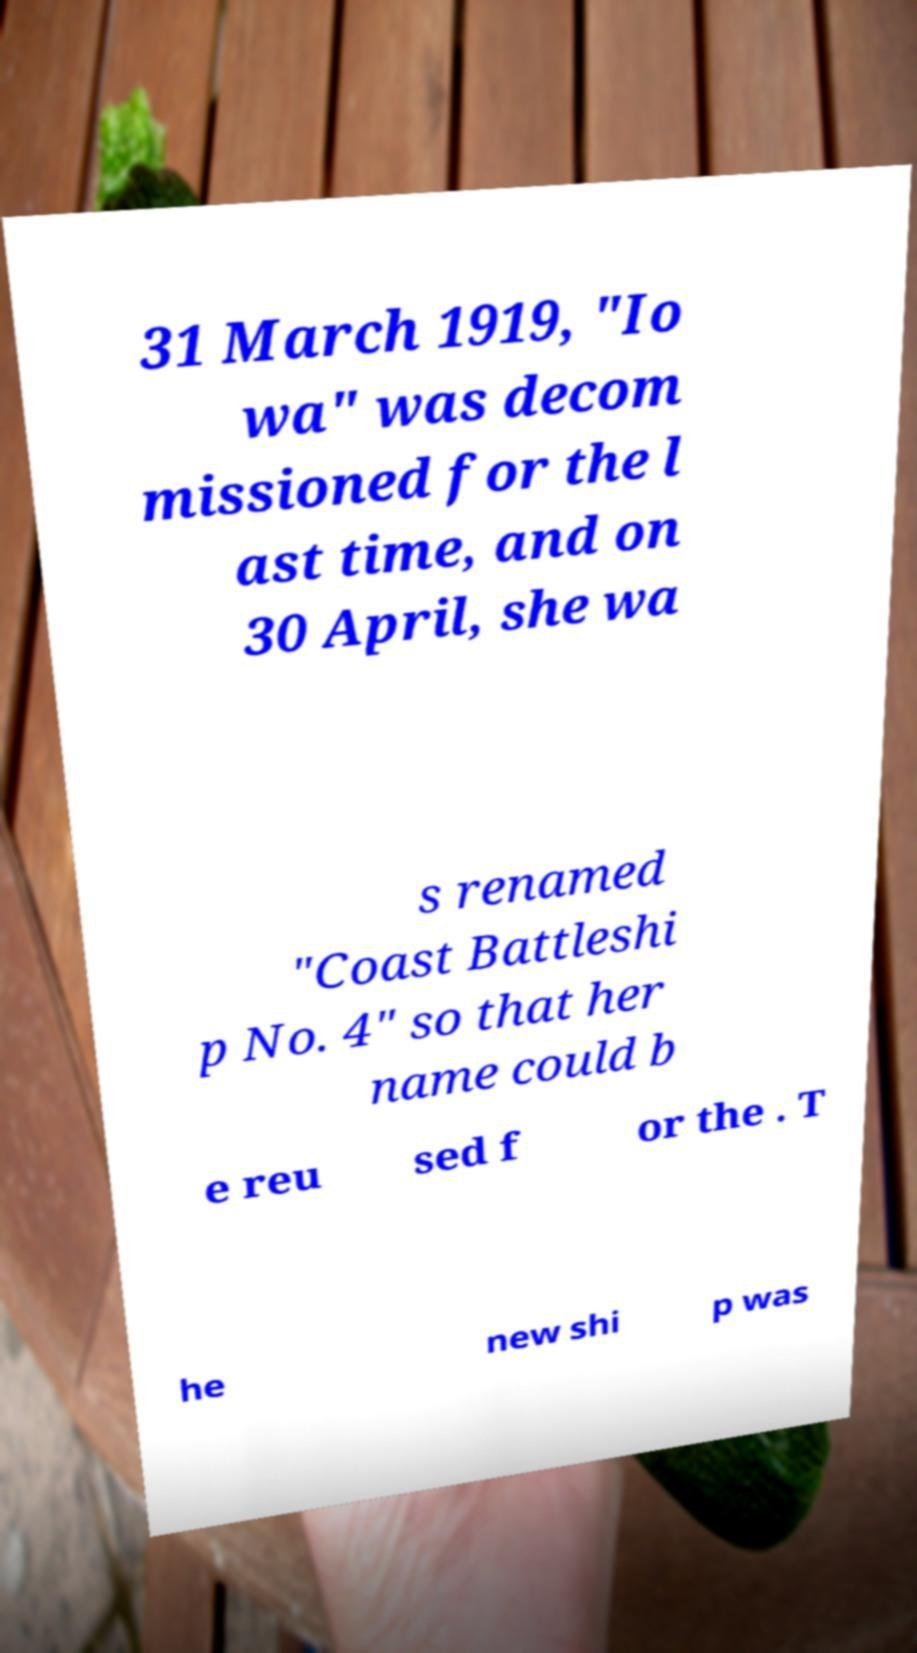I need the written content from this picture converted into text. Can you do that? 31 March 1919, "Io wa" was decom missioned for the l ast time, and on 30 April, she wa s renamed "Coast Battleshi p No. 4" so that her name could b e reu sed f or the . T he new shi p was 